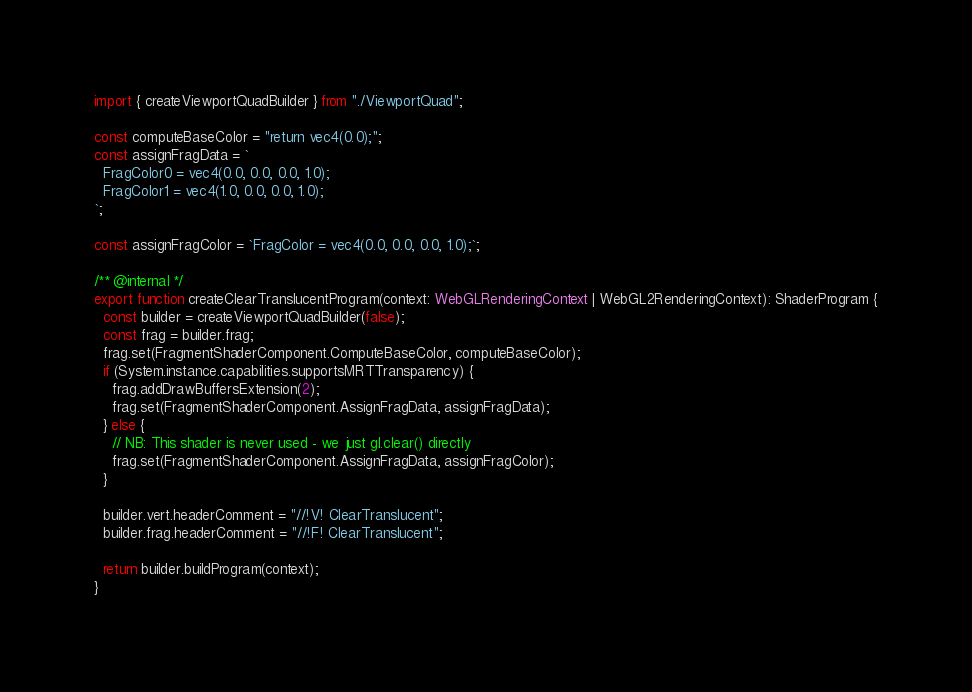<code> <loc_0><loc_0><loc_500><loc_500><_TypeScript_>import { createViewportQuadBuilder } from "./ViewportQuad";

const computeBaseColor = "return vec4(0.0);";
const assignFragData = `
  FragColor0 = vec4(0.0, 0.0, 0.0, 1.0);
  FragColor1 = vec4(1.0, 0.0, 0.0, 1.0);
`;

const assignFragColor = `FragColor = vec4(0.0, 0.0, 0.0, 1.0);`;

/** @internal */
export function createClearTranslucentProgram(context: WebGLRenderingContext | WebGL2RenderingContext): ShaderProgram {
  const builder = createViewportQuadBuilder(false);
  const frag = builder.frag;
  frag.set(FragmentShaderComponent.ComputeBaseColor, computeBaseColor);
  if (System.instance.capabilities.supportsMRTTransparency) {
    frag.addDrawBuffersExtension(2);
    frag.set(FragmentShaderComponent.AssignFragData, assignFragData);
  } else {
    // NB: This shader is never used - we just gl.clear() directly
    frag.set(FragmentShaderComponent.AssignFragData, assignFragColor);
  }

  builder.vert.headerComment = "//!V! ClearTranslucent";
  builder.frag.headerComment = "//!F! ClearTranslucent";

  return builder.buildProgram(context);
}
</code> 